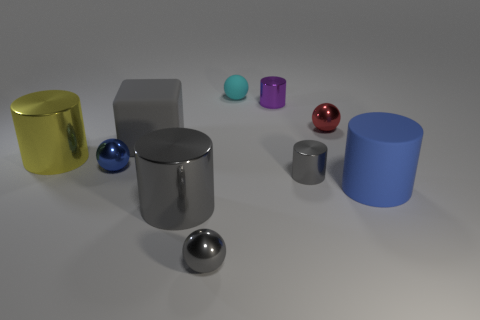Describe the lighting and shadows in the scene. The lighting appears to be coming from above as indicated by the soft shadows being cast underneath each object, suggesting a diffuse light source in the scene. 